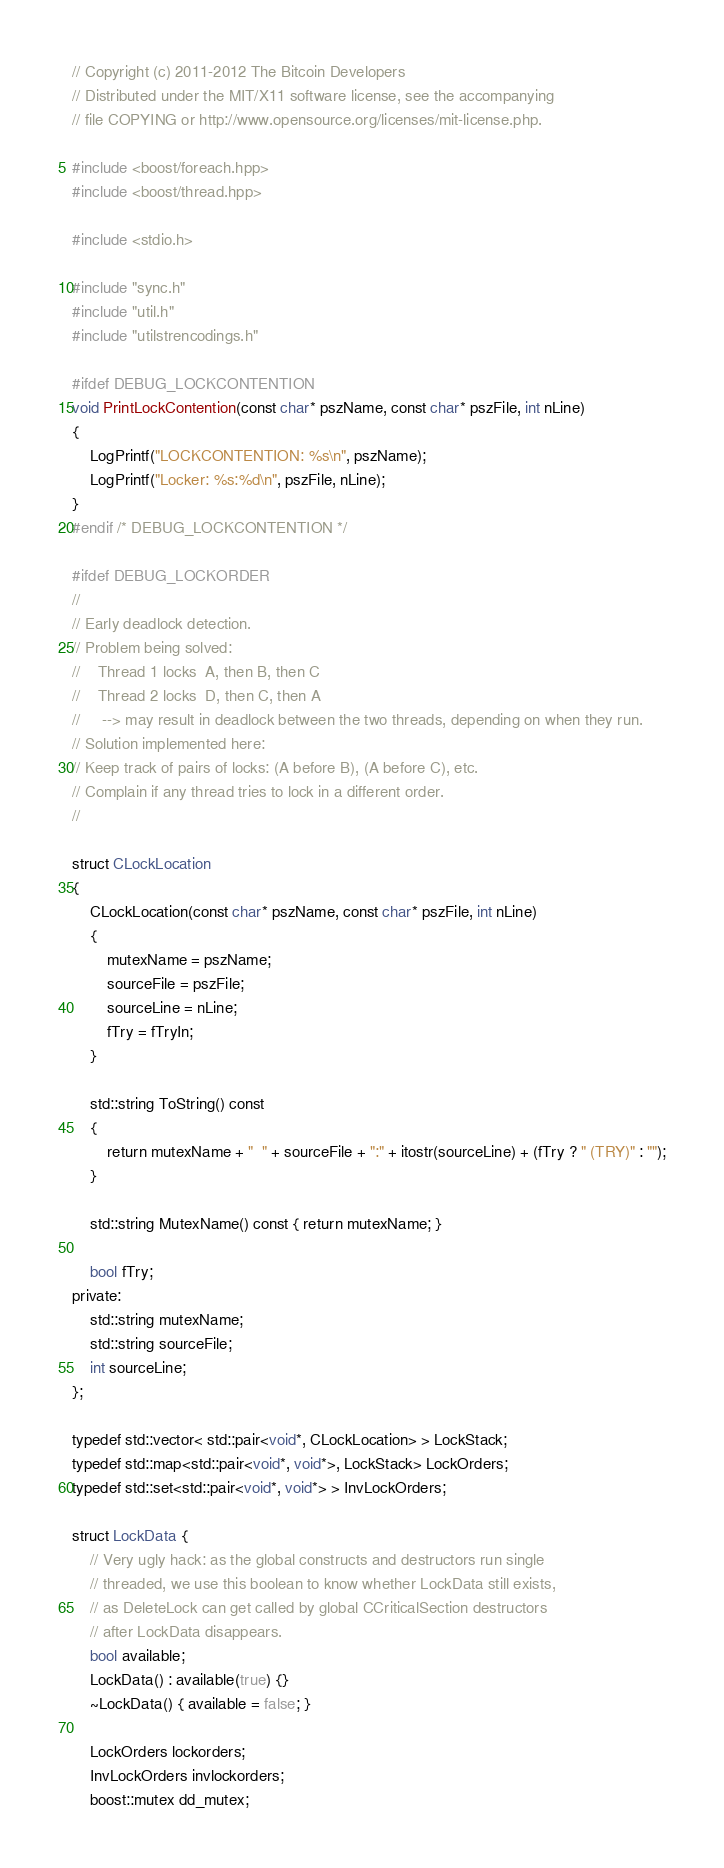<code> <loc_0><loc_0><loc_500><loc_500><_C++_>// Copyright (c) 2011-2012 The Bitcoin Developers
// Distributed under the MIT/X11 software license, see the accompanying
// file COPYING or http://www.opensource.org/licenses/mit-license.php.

#include <boost/foreach.hpp>
#include <boost/thread.hpp>

#include <stdio.h>

#include "sync.h"
#include "util.h"
#include "utilstrencodings.h"

#ifdef DEBUG_LOCKCONTENTION
void PrintLockContention(const char* pszName, const char* pszFile, int nLine)
{
    LogPrintf("LOCKCONTENTION: %s\n", pszName);
    LogPrintf("Locker: %s:%d\n", pszFile, nLine);
}
#endif /* DEBUG_LOCKCONTENTION */

#ifdef DEBUG_LOCKORDER
//
// Early deadlock detection.
// Problem being solved:
//    Thread 1 locks  A, then B, then C
//    Thread 2 locks  D, then C, then A
//     --> may result in deadlock between the two threads, depending on when they run.
// Solution implemented here:
// Keep track of pairs of locks: (A before B), (A before C), etc.
// Complain if any thread tries to lock in a different order.
//

struct CLockLocation
{
    CLockLocation(const char* pszName, const char* pszFile, int nLine)
    {
        mutexName = pszName;
        sourceFile = pszFile;
        sourceLine = nLine;
        fTry = fTryIn;
    }

    std::string ToString() const
    {
        return mutexName + "  " + sourceFile + ":" + itostr(sourceLine) + (fTry ? " (TRY)" : "");
    }

    std::string MutexName() const { return mutexName; }

    bool fTry;
private:
    std::string mutexName;
    std::string sourceFile;
    int sourceLine;
};

typedef std::vector< std::pair<void*, CLockLocation> > LockStack;
typedef std::map<std::pair<void*, void*>, LockStack> LockOrders;
typedef std::set<std::pair<void*, void*> > InvLockOrders;

struct LockData {
    // Very ugly hack: as the global constructs and destructors run single
    // threaded, we use this boolean to know whether LockData still exists,
    // as DeleteLock can get called by global CCriticalSection destructors
    // after LockData disappears.
    bool available;
    LockData() : available(true) {}
    ~LockData() { available = false; }

    LockOrders lockorders;
    InvLockOrders invlockorders;
    boost::mutex dd_mutex;</code> 